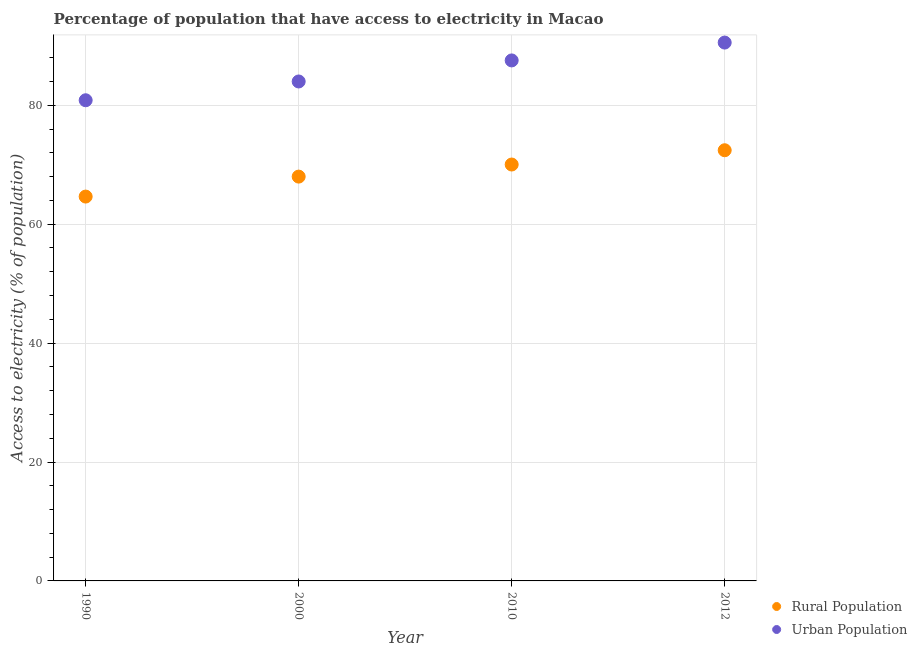How many different coloured dotlines are there?
Keep it short and to the point. 2. What is the percentage of urban population having access to electricity in 2012?
Your answer should be compact. 90.54. Across all years, what is the maximum percentage of urban population having access to electricity?
Your response must be concise. 90.54. Across all years, what is the minimum percentage of urban population having access to electricity?
Your answer should be very brief. 80.84. In which year was the percentage of urban population having access to electricity maximum?
Offer a very short reply. 2012. What is the total percentage of urban population having access to electricity in the graph?
Offer a terse response. 342.92. What is the difference between the percentage of rural population having access to electricity in 1990 and that in 2012?
Keep it short and to the point. -7.79. What is the difference between the percentage of rural population having access to electricity in 1990 and the percentage of urban population having access to electricity in 2000?
Give a very brief answer. -19.36. What is the average percentage of rural population having access to electricity per year?
Your answer should be compact. 68.78. In the year 2000, what is the difference between the percentage of rural population having access to electricity and percentage of urban population having access to electricity?
Offer a terse response. -16. What is the ratio of the percentage of urban population having access to electricity in 1990 to that in 2012?
Give a very brief answer. 0.89. Is the percentage of urban population having access to electricity in 1990 less than that in 2012?
Give a very brief answer. Yes. What is the difference between the highest and the second highest percentage of rural population having access to electricity?
Provide a short and direct response. 2.4. What is the difference between the highest and the lowest percentage of urban population having access to electricity?
Provide a short and direct response. 9.7. Is the sum of the percentage of urban population having access to electricity in 2000 and 2010 greater than the maximum percentage of rural population having access to electricity across all years?
Ensure brevity in your answer.  Yes. How many dotlines are there?
Ensure brevity in your answer.  2. Does the graph contain any zero values?
Offer a very short reply. No. Does the graph contain grids?
Your response must be concise. Yes. How many legend labels are there?
Your answer should be very brief. 2. How are the legend labels stacked?
Make the answer very short. Vertical. What is the title of the graph?
Offer a terse response. Percentage of population that have access to electricity in Macao. Does "Non-residents" appear as one of the legend labels in the graph?
Provide a short and direct response. No. What is the label or title of the Y-axis?
Keep it short and to the point. Access to electricity (% of population). What is the Access to electricity (% of population) of Rural Population in 1990?
Your response must be concise. 64.64. What is the Access to electricity (% of population) of Urban Population in 1990?
Offer a terse response. 80.84. What is the Access to electricity (% of population) of Rural Population in 2010?
Keep it short and to the point. 70.03. What is the Access to electricity (% of population) of Urban Population in 2010?
Give a very brief answer. 87.54. What is the Access to electricity (% of population) in Rural Population in 2012?
Keep it short and to the point. 72.43. What is the Access to electricity (% of population) in Urban Population in 2012?
Your answer should be compact. 90.54. Across all years, what is the maximum Access to electricity (% of population) of Rural Population?
Offer a terse response. 72.43. Across all years, what is the maximum Access to electricity (% of population) of Urban Population?
Offer a very short reply. 90.54. Across all years, what is the minimum Access to electricity (% of population) of Rural Population?
Your answer should be very brief. 64.64. Across all years, what is the minimum Access to electricity (% of population) in Urban Population?
Make the answer very short. 80.84. What is the total Access to electricity (% of population) of Rural Population in the graph?
Give a very brief answer. 275.11. What is the total Access to electricity (% of population) in Urban Population in the graph?
Your response must be concise. 342.92. What is the difference between the Access to electricity (% of population) in Rural Population in 1990 and that in 2000?
Make the answer very short. -3.36. What is the difference between the Access to electricity (% of population) in Urban Population in 1990 and that in 2000?
Provide a short and direct response. -3.16. What is the difference between the Access to electricity (% of population) in Rural Population in 1990 and that in 2010?
Ensure brevity in your answer.  -5.39. What is the difference between the Access to electricity (% of population) of Urban Population in 1990 and that in 2010?
Give a very brief answer. -6.7. What is the difference between the Access to electricity (% of population) in Rural Population in 1990 and that in 2012?
Provide a succinct answer. -7.79. What is the difference between the Access to electricity (% of population) of Urban Population in 1990 and that in 2012?
Make the answer very short. -9.7. What is the difference between the Access to electricity (% of population) in Rural Population in 2000 and that in 2010?
Offer a very short reply. -2.03. What is the difference between the Access to electricity (% of population) of Urban Population in 2000 and that in 2010?
Offer a terse response. -3.54. What is the difference between the Access to electricity (% of population) in Rural Population in 2000 and that in 2012?
Your answer should be very brief. -4.43. What is the difference between the Access to electricity (% of population) in Urban Population in 2000 and that in 2012?
Give a very brief answer. -6.54. What is the difference between the Access to electricity (% of population) in Rural Population in 2010 and that in 2012?
Your answer should be very brief. -2.4. What is the difference between the Access to electricity (% of population) in Urban Population in 2010 and that in 2012?
Provide a short and direct response. -3. What is the difference between the Access to electricity (% of population) of Rural Population in 1990 and the Access to electricity (% of population) of Urban Population in 2000?
Your response must be concise. -19.36. What is the difference between the Access to electricity (% of population) in Rural Population in 1990 and the Access to electricity (% of population) in Urban Population in 2010?
Provide a succinct answer. -22.9. What is the difference between the Access to electricity (% of population) of Rural Population in 1990 and the Access to electricity (% of population) of Urban Population in 2012?
Offer a terse response. -25.9. What is the difference between the Access to electricity (% of population) of Rural Population in 2000 and the Access to electricity (% of population) of Urban Population in 2010?
Your answer should be compact. -19.54. What is the difference between the Access to electricity (% of population) of Rural Population in 2000 and the Access to electricity (% of population) of Urban Population in 2012?
Make the answer very short. -22.54. What is the difference between the Access to electricity (% of population) of Rural Population in 2010 and the Access to electricity (% of population) of Urban Population in 2012?
Your answer should be very brief. -20.51. What is the average Access to electricity (% of population) in Rural Population per year?
Your response must be concise. 68.78. What is the average Access to electricity (% of population) of Urban Population per year?
Give a very brief answer. 85.73. In the year 1990, what is the difference between the Access to electricity (% of population) of Rural Population and Access to electricity (% of population) of Urban Population?
Your answer should be compact. -16.2. In the year 2000, what is the difference between the Access to electricity (% of population) in Rural Population and Access to electricity (% of population) in Urban Population?
Your answer should be compact. -16. In the year 2010, what is the difference between the Access to electricity (% of population) in Rural Population and Access to electricity (% of population) in Urban Population?
Your answer should be very brief. -17.51. In the year 2012, what is the difference between the Access to electricity (% of population) of Rural Population and Access to electricity (% of population) of Urban Population?
Offer a terse response. -18.11. What is the ratio of the Access to electricity (% of population) in Rural Population in 1990 to that in 2000?
Ensure brevity in your answer.  0.95. What is the ratio of the Access to electricity (% of population) of Urban Population in 1990 to that in 2000?
Ensure brevity in your answer.  0.96. What is the ratio of the Access to electricity (% of population) of Rural Population in 1990 to that in 2010?
Your answer should be very brief. 0.92. What is the ratio of the Access to electricity (% of population) in Urban Population in 1990 to that in 2010?
Make the answer very short. 0.92. What is the ratio of the Access to electricity (% of population) of Rural Population in 1990 to that in 2012?
Provide a succinct answer. 0.89. What is the ratio of the Access to electricity (% of population) of Urban Population in 1990 to that in 2012?
Give a very brief answer. 0.89. What is the ratio of the Access to electricity (% of population) of Urban Population in 2000 to that in 2010?
Your answer should be very brief. 0.96. What is the ratio of the Access to electricity (% of population) of Rural Population in 2000 to that in 2012?
Your answer should be very brief. 0.94. What is the ratio of the Access to electricity (% of population) in Urban Population in 2000 to that in 2012?
Make the answer very short. 0.93. What is the ratio of the Access to electricity (% of population) in Rural Population in 2010 to that in 2012?
Your answer should be compact. 0.97. What is the ratio of the Access to electricity (% of population) in Urban Population in 2010 to that in 2012?
Your answer should be very brief. 0.97. What is the difference between the highest and the second highest Access to electricity (% of population) in Rural Population?
Offer a terse response. 2.4. What is the difference between the highest and the second highest Access to electricity (% of population) of Urban Population?
Keep it short and to the point. 3. What is the difference between the highest and the lowest Access to electricity (% of population) of Rural Population?
Keep it short and to the point. 7.79. What is the difference between the highest and the lowest Access to electricity (% of population) of Urban Population?
Ensure brevity in your answer.  9.7. 